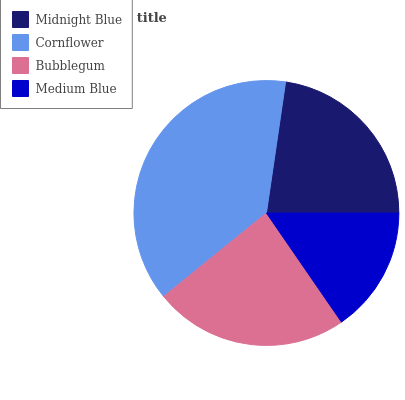Is Medium Blue the minimum?
Answer yes or no. Yes. Is Cornflower the maximum?
Answer yes or no. Yes. Is Bubblegum the minimum?
Answer yes or no. No. Is Bubblegum the maximum?
Answer yes or no. No. Is Cornflower greater than Bubblegum?
Answer yes or no. Yes. Is Bubblegum less than Cornflower?
Answer yes or no. Yes. Is Bubblegum greater than Cornflower?
Answer yes or no. No. Is Cornflower less than Bubblegum?
Answer yes or no. No. Is Bubblegum the high median?
Answer yes or no. Yes. Is Midnight Blue the low median?
Answer yes or no. Yes. Is Cornflower the high median?
Answer yes or no. No. Is Bubblegum the low median?
Answer yes or no. No. 